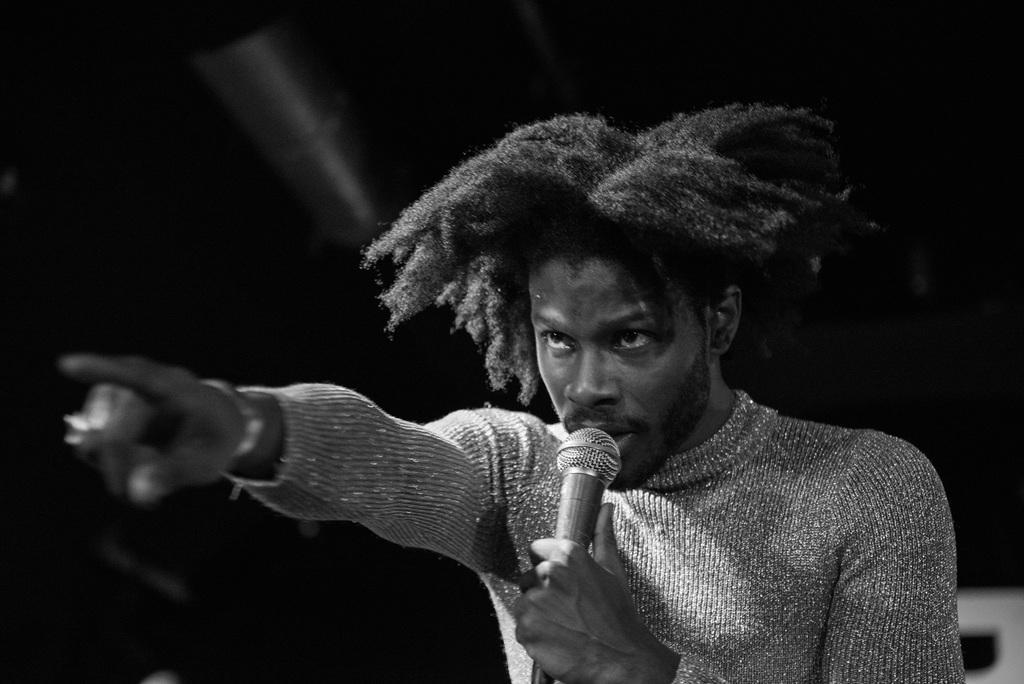In one or two sentences, can you explain what this image depicts? Here we see a man standing and singing with the help of a microphone. 